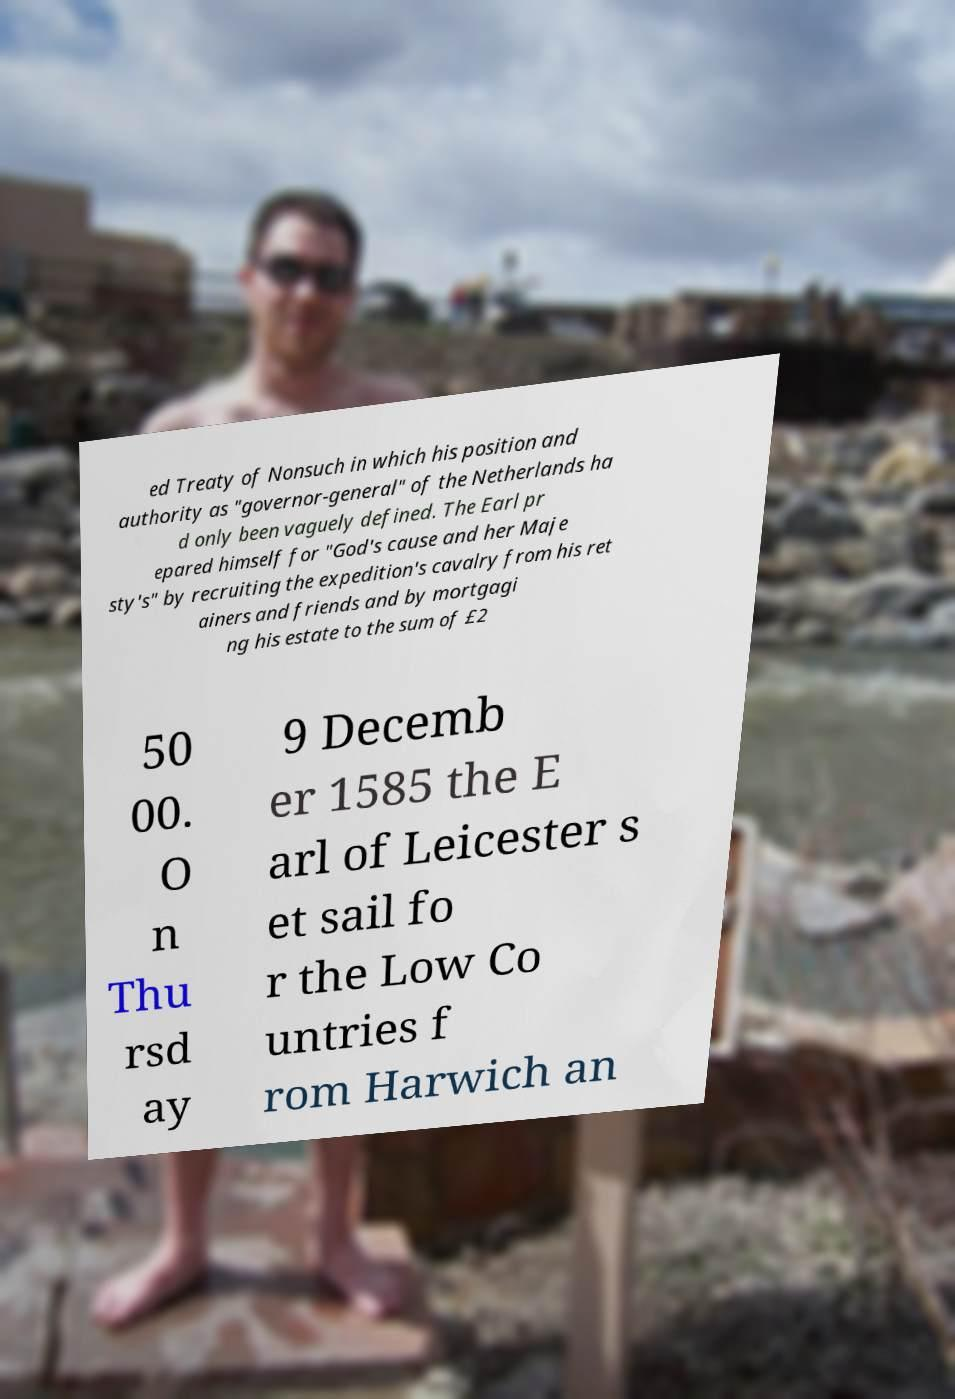What messages or text are displayed in this image? I need them in a readable, typed format. ed Treaty of Nonsuch in which his position and authority as "governor-general" of the Netherlands ha d only been vaguely defined. The Earl pr epared himself for "God's cause and her Maje sty's" by recruiting the expedition's cavalry from his ret ainers and friends and by mortgagi ng his estate to the sum of £2 50 00. O n Thu rsd ay 9 Decemb er 1585 the E arl of Leicester s et sail fo r the Low Co untries f rom Harwich an 